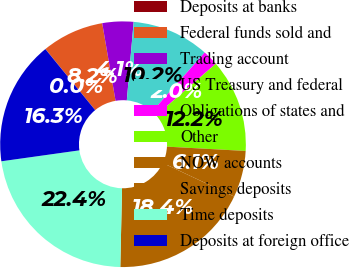Convert chart to OTSL. <chart><loc_0><loc_0><loc_500><loc_500><pie_chart><fcel>Deposits at banks<fcel>Federal funds sold and<fcel>Trading account<fcel>US Treasury and federal<fcel>Obligations of states and<fcel>Other<fcel>NOW accounts<fcel>Savings deposits<fcel>Time deposits<fcel>Deposits at foreign office<nl><fcel>0.02%<fcel>8.17%<fcel>4.09%<fcel>10.2%<fcel>2.05%<fcel>12.24%<fcel>6.13%<fcel>18.35%<fcel>22.43%<fcel>16.32%<nl></chart> 